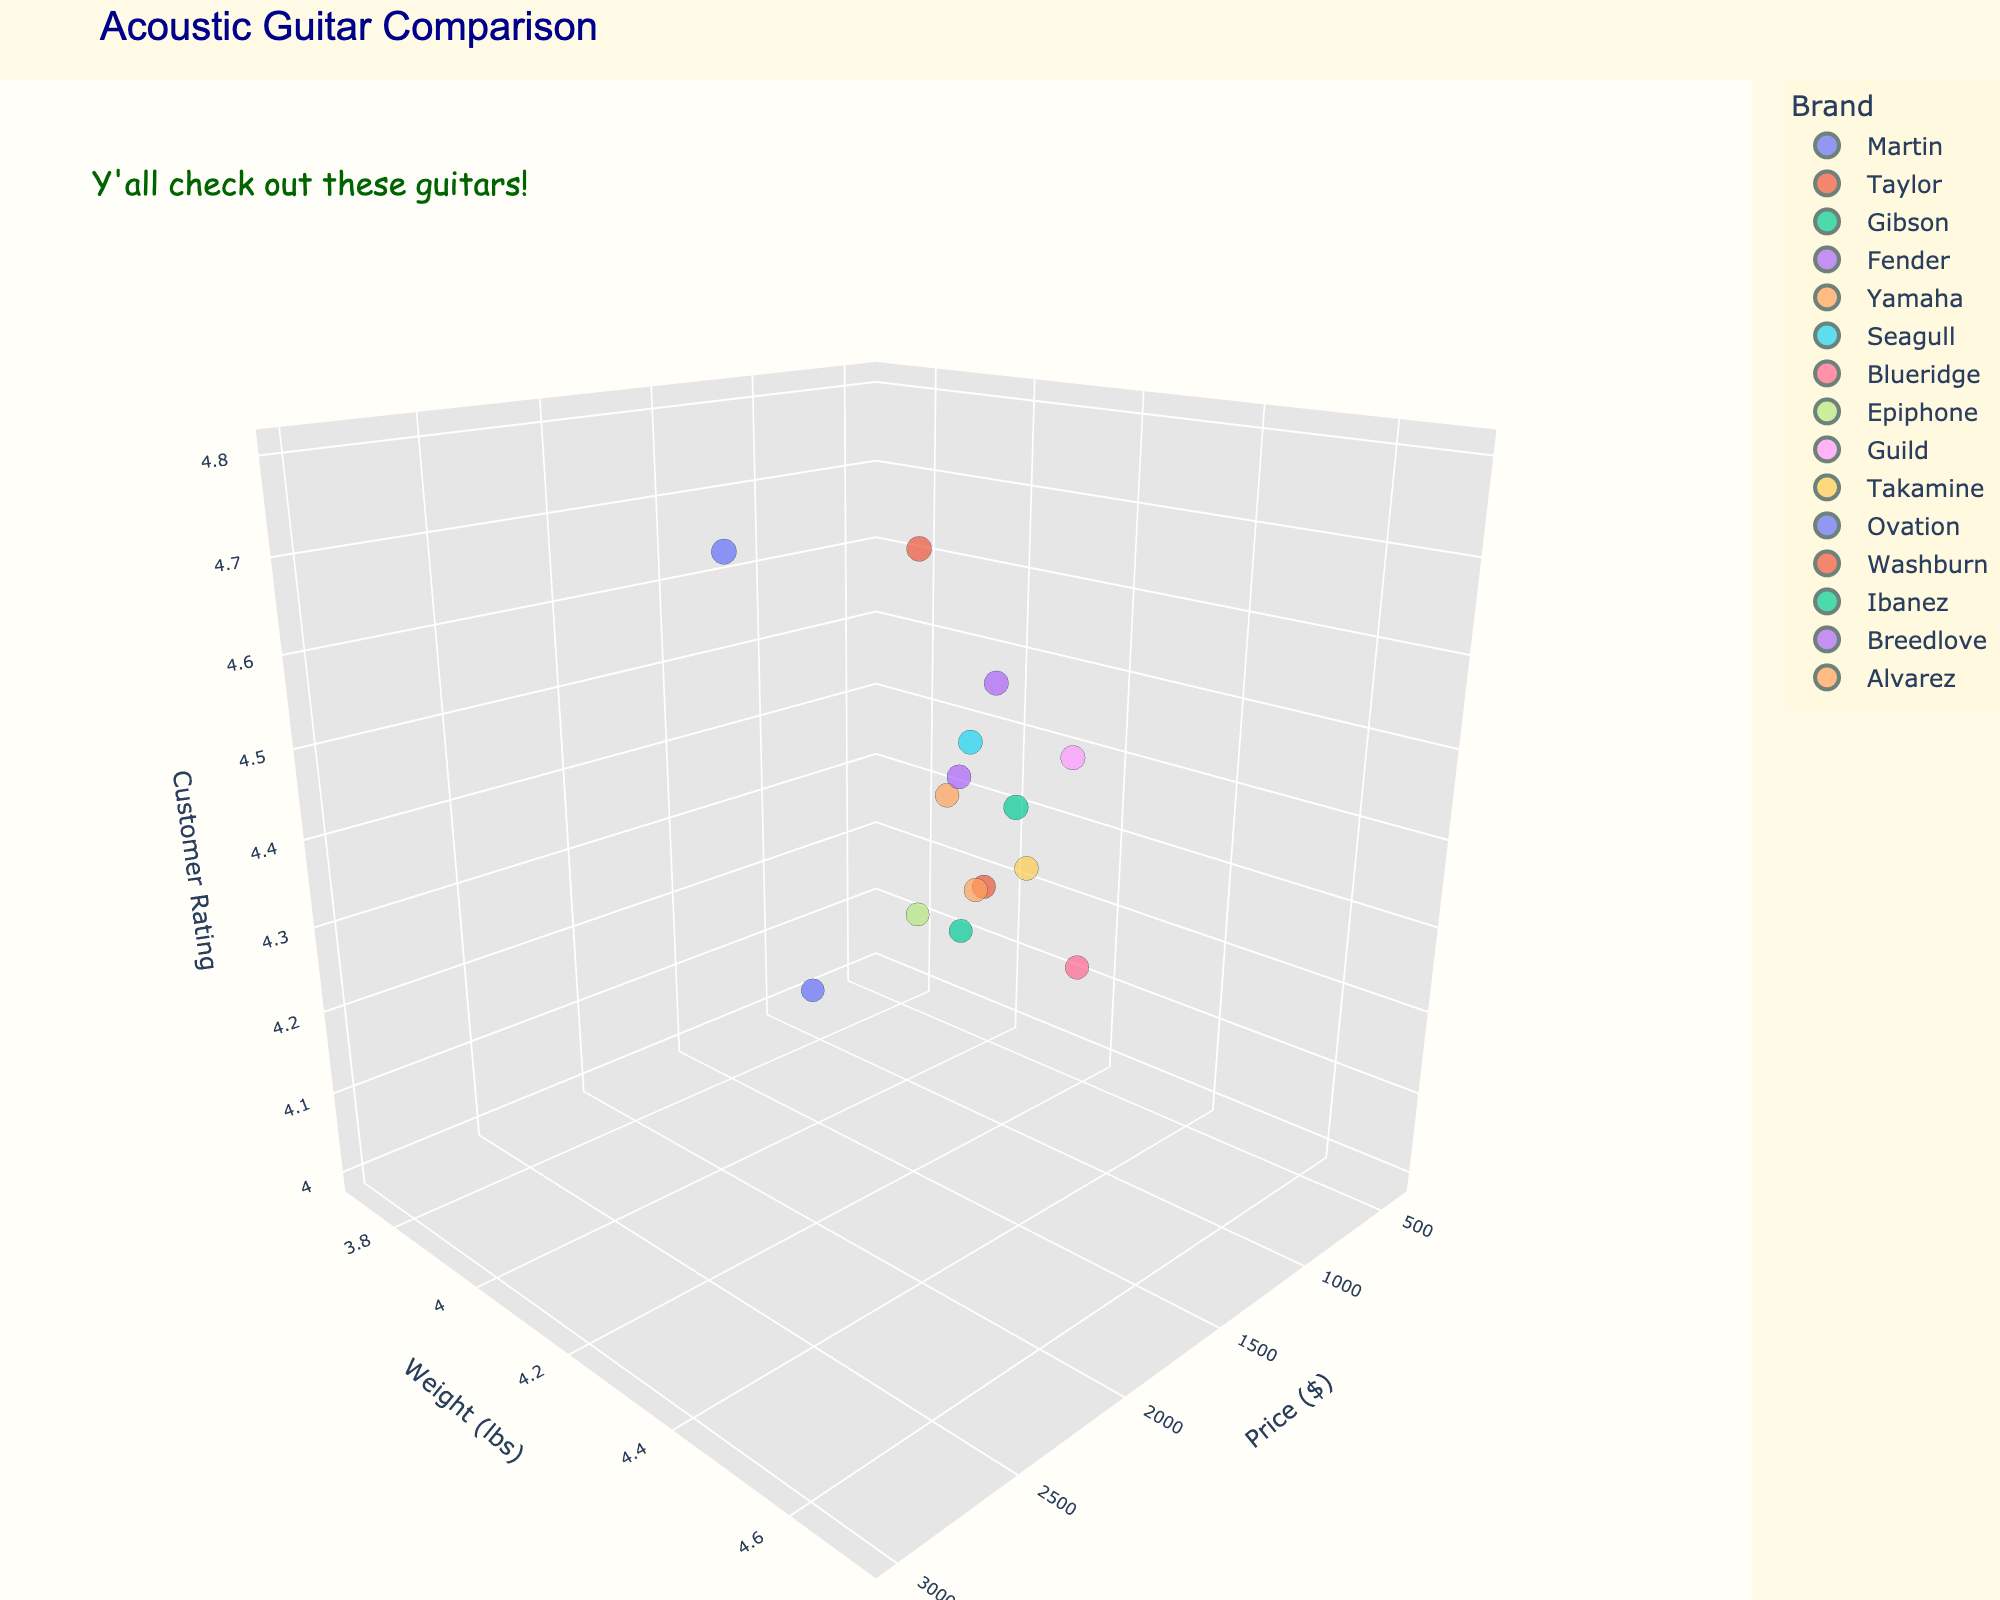How many brands of guitars are represented in the plot? Count the number of unique data points visible in the plot. Each data point represents a different brand. Counting the different data points gives us the total number of brands.
Answer: 15 What's the title of the plot? Read the text at the top of the figure where the title is usually located.
Answer: Acoustic Guitar Comparison Which brand has the highest customer rating? Look at the z-axis (Customer Rating) and identify the data point that is located at the highest position.
Answer: Martin What's the price range of the guitars shown in the plot? Identify the lowest and highest values on the x-axis (Price). The lowest price data point is Epiphone at $399, and the highest is Martin at $2999.
Answer: $399 to $2999 Which guitar brand has the lowest weight? Look for the data point that is the lowest on the y-axis (Weight). The lowest weight data point is Ovation at 3.7 lbs.
Answer: Ovation What's the average customer rating of the guitars priced above $1000? Identify the data points with prices above $1000, and then calculate the average of their customer ratings. The qualified data points and ratings are Martin (4.8), Taylor (4.7), Gibson (4.6), and Guild (4.5). Sum these ratings and divide by the number of points: (4.8 + 4.7 + 4.6 + 4.5) / 4 = 18.6 / 4 = 4.65.
Answer: 4.65 Which guitar brand with a price less than or equal to $800 has the highest customer rating? Filter the data points by those with a price less than or equal to $800, and then choose the one with the highest customer rating. The brands and ratings in this range are Fender (4.5), Yamaha (4.3), Seagull (4.4), Ovation (4.0), Washburn (4.2), Epiphone (4.1), and Ibanez (4.1). The highest rating is Fender at 4.5.
Answer: Fender Compare the weights of Gibson and Fender guitars. Which one is heavier? Locate the data points for Gibson and Fender on the y-axis. Gibson has a weight of 4.7 lbs, and Fender has a weight of 4.1 lbs.
Answer: Gibson What's the overall theme color of the plot background? Observe the color used in the background of the plot.
Answer: Light yellow (beige) Is there any annotation on the plot? If so, what does it say? Look for any text not part of the axes titles, legend, or data labels. There is an annotation on the plot.
Answer: Y'all check out these guitars! 